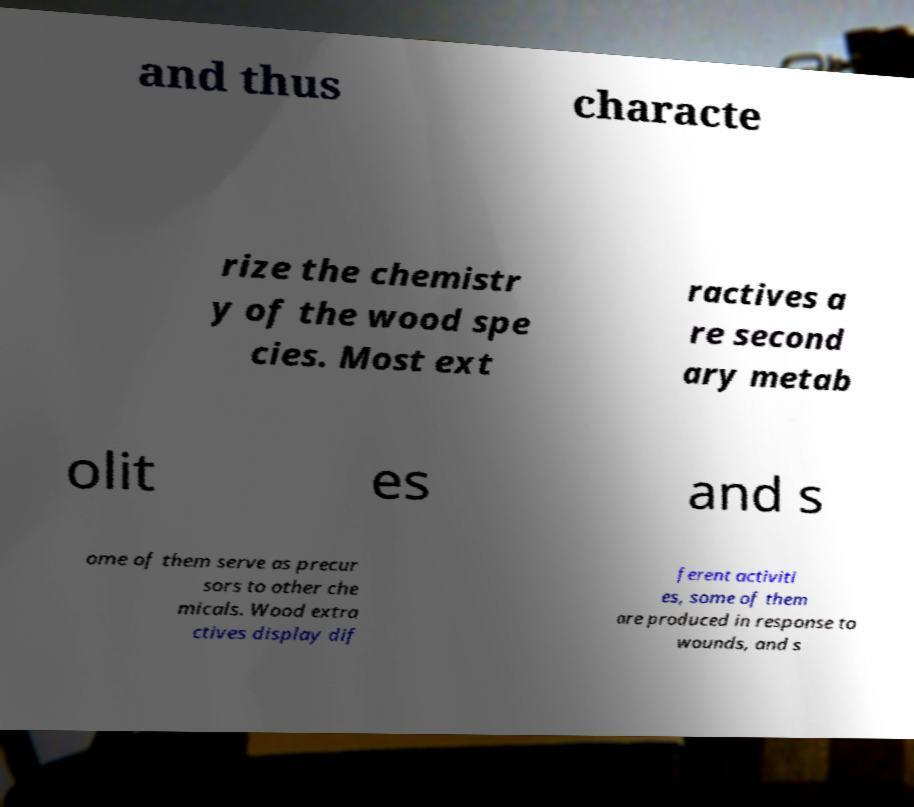Please identify and transcribe the text found in this image. and thus characte rize the chemistr y of the wood spe cies. Most ext ractives a re second ary metab olit es and s ome of them serve as precur sors to other che micals. Wood extra ctives display dif ferent activiti es, some of them are produced in response to wounds, and s 